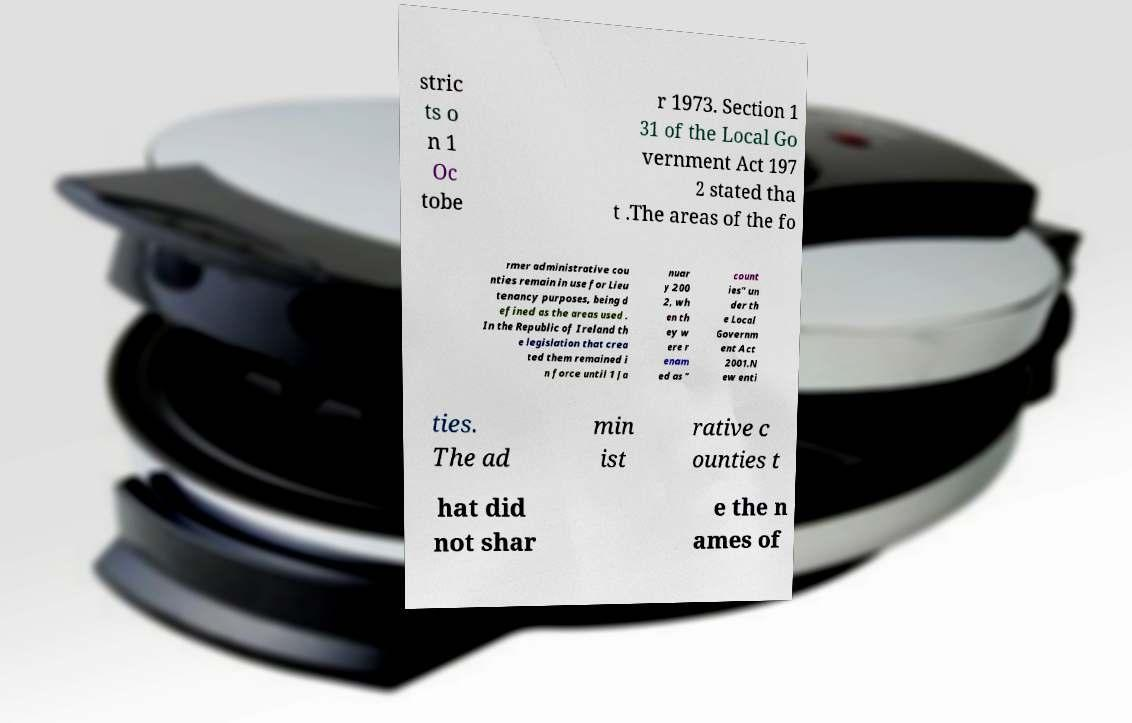Please identify and transcribe the text found in this image. stric ts o n 1 Oc tobe r 1973. Section 1 31 of the Local Go vernment Act 197 2 stated tha t .The areas of the fo rmer administrative cou nties remain in use for Lieu tenancy purposes, being d efined as the areas used . In the Republic of Ireland th e legislation that crea ted them remained i n force until 1 Ja nuar y 200 2, wh en th ey w ere r enam ed as " count ies" un der th e Local Governm ent Act 2001.N ew enti ties. The ad min ist rative c ounties t hat did not shar e the n ames of 